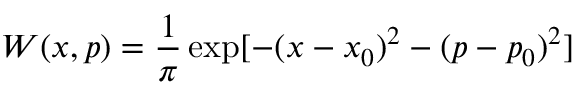<formula> <loc_0><loc_0><loc_500><loc_500>W ( x , p ) = \frac { 1 } { \pi } \exp [ - ( x - x _ { 0 } ) ^ { 2 } - ( p - p _ { 0 } ) ^ { 2 } ]</formula> 